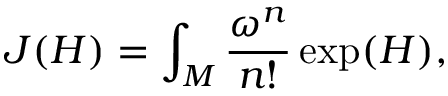<formula> <loc_0><loc_0><loc_500><loc_500>J ( H ) = \int _ { M } \frac { \omega ^ { n } } { n ! } \exp ( H ) ,</formula> 